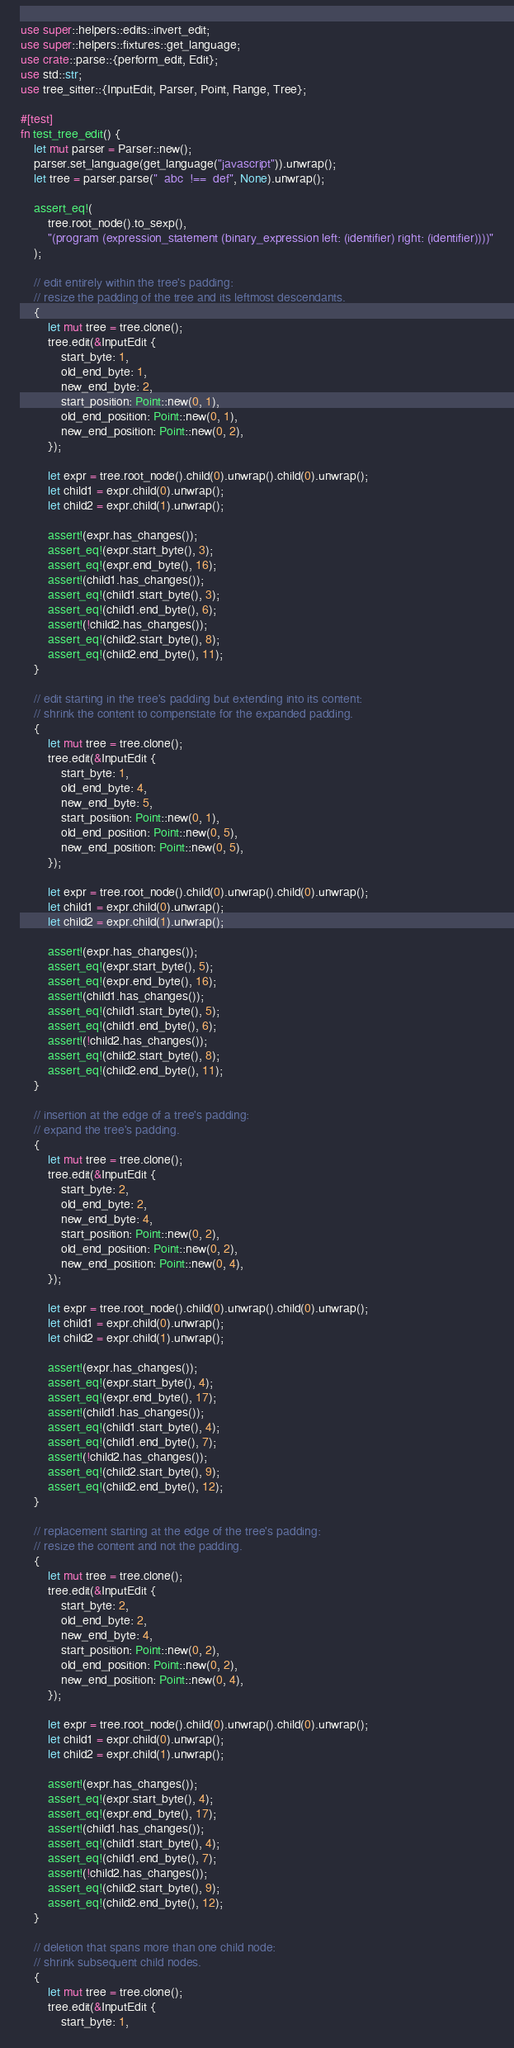<code> <loc_0><loc_0><loc_500><loc_500><_Rust_>use super::helpers::edits::invert_edit;
use super::helpers::fixtures::get_language;
use crate::parse::{perform_edit, Edit};
use std::str;
use tree_sitter::{InputEdit, Parser, Point, Range, Tree};

#[test]
fn test_tree_edit() {
    let mut parser = Parser::new();
    parser.set_language(get_language("javascript")).unwrap();
    let tree = parser.parse("  abc  !==  def", None).unwrap();

    assert_eq!(
        tree.root_node().to_sexp(),
        "(program (expression_statement (binary_expression left: (identifier) right: (identifier))))"
    );

    // edit entirely within the tree's padding:
    // resize the padding of the tree and its leftmost descendants.
    {
        let mut tree = tree.clone();
        tree.edit(&InputEdit {
            start_byte: 1,
            old_end_byte: 1,
            new_end_byte: 2,
            start_position: Point::new(0, 1),
            old_end_position: Point::new(0, 1),
            new_end_position: Point::new(0, 2),
        });

        let expr = tree.root_node().child(0).unwrap().child(0).unwrap();
        let child1 = expr.child(0).unwrap();
        let child2 = expr.child(1).unwrap();

        assert!(expr.has_changes());
        assert_eq!(expr.start_byte(), 3);
        assert_eq!(expr.end_byte(), 16);
        assert!(child1.has_changes());
        assert_eq!(child1.start_byte(), 3);
        assert_eq!(child1.end_byte(), 6);
        assert!(!child2.has_changes());
        assert_eq!(child2.start_byte(), 8);
        assert_eq!(child2.end_byte(), 11);
    }

    // edit starting in the tree's padding but extending into its content:
    // shrink the content to compenstate for the expanded padding.
    {
        let mut tree = tree.clone();
        tree.edit(&InputEdit {
            start_byte: 1,
            old_end_byte: 4,
            new_end_byte: 5,
            start_position: Point::new(0, 1),
            old_end_position: Point::new(0, 5),
            new_end_position: Point::new(0, 5),
        });

        let expr = tree.root_node().child(0).unwrap().child(0).unwrap();
        let child1 = expr.child(0).unwrap();
        let child2 = expr.child(1).unwrap();

        assert!(expr.has_changes());
        assert_eq!(expr.start_byte(), 5);
        assert_eq!(expr.end_byte(), 16);
        assert!(child1.has_changes());
        assert_eq!(child1.start_byte(), 5);
        assert_eq!(child1.end_byte(), 6);
        assert!(!child2.has_changes());
        assert_eq!(child2.start_byte(), 8);
        assert_eq!(child2.end_byte(), 11);
    }

    // insertion at the edge of a tree's padding:
    // expand the tree's padding.
    {
        let mut tree = tree.clone();
        tree.edit(&InputEdit {
            start_byte: 2,
            old_end_byte: 2,
            new_end_byte: 4,
            start_position: Point::new(0, 2),
            old_end_position: Point::new(0, 2),
            new_end_position: Point::new(0, 4),
        });

        let expr = tree.root_node().child(0).unwrap().child(0).unwrap();
        let child1 = expr.child(0).unwrap();
        let child2 = expr.child(1).unwrap();

        assert!(expr.has_changes());
        assert_eq!(expr.start_byte(), 4);
        assert_eq!(expr.end_byte(), 17);
        assert!(child1.has_changes());
        assert_eq!(child1.start_byte(), 4);
        assert_eq!(child1.end_byte(), 7);
        assert!(!child2.has_changes());
        assert_eq!(child2.start_byte(), 9);
        assert_eq!(child2.end_byte(), 12);
    }

    // replacement starting at the edge of the tree's padding:
    // resize the content and not the padding.
    {
        let mut tree = tree.clone();
        tree.edit(&InputEdit {
            start_byte: 2,
            old_end_byte: 2,
            new_end_byte: 4,
            start_position: Point::new(0, 2),
            old_end_position: Point::new(0, 2),
            new_end_position: Point::new(0, 4),
        });

        let expr = tree.root_node().child(0).unwrap().child(0).unwrap();
        let child1 = expr.child(0).unwrap();
        let child2 = expr.child(1).unwrap();

        assert!(expr.has_changes());
        assert_eq!(expr.start_byte(), 4);
        assert_eq!(expr.end_byte(), 17);
        assert!(child1.has_changes());
        assert_eq!(child1.start_byte(), 4);
        assert_eq!(child1.end_byte(), 7);
        assert!(!child2.has_changes());
        assert_eq!(child2.start_byte(), 9);
        assert_eq!(child2.end_byte(), 12);
    }

    // deletion that spans more than one child node:
    // shrink subsequent child nodes.
    {
        let mut tree = tree.clone();
        tree.edit(&InputEdit {
            start_byte: 1,</code> 